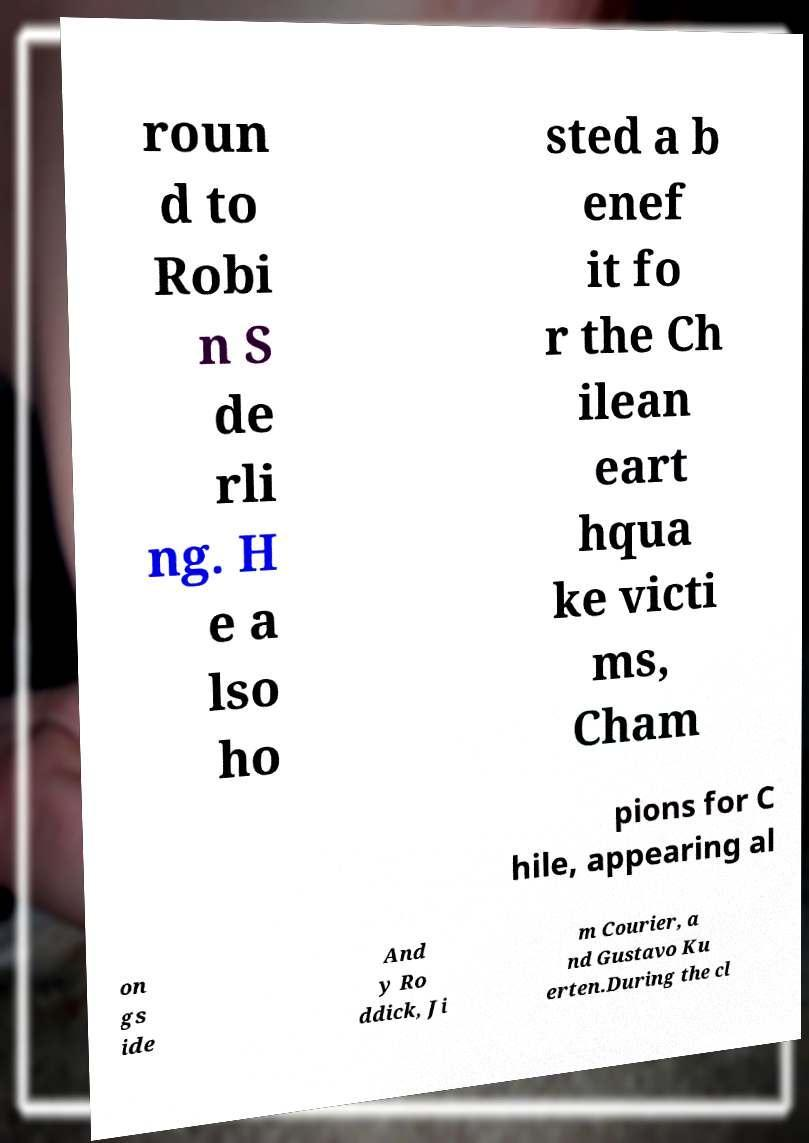I need the written content from this picture converted into text. Can you do that? roun d to Robi n S de rli ng. H e a lso ho sted a b enef it fo r the Ch ilean eart hqua ke victi ms, Cham pions for C hile, appearing al on gs ide And y Ro ddick, Ji m Courier, a nd Gustavo Ku erten.During the cl 